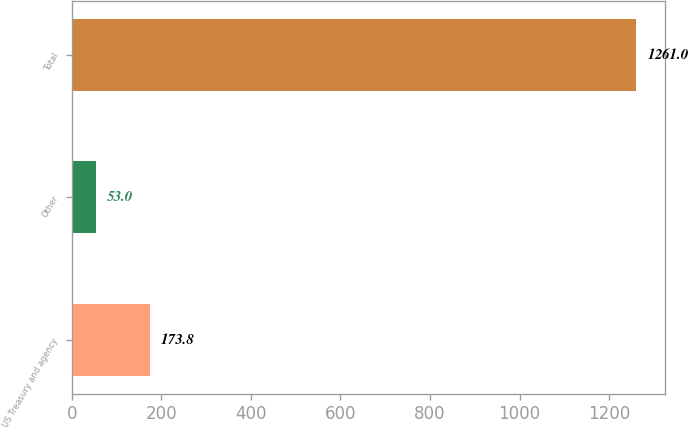<chart> <loc_0><loc_0><loc_500><loc_500><bar_chart><fcel>US Treasury and agency<fcel>Other<fcel>Total<nl><fcel>173.8<fcel>53<fcel>1261<nl></chart> 